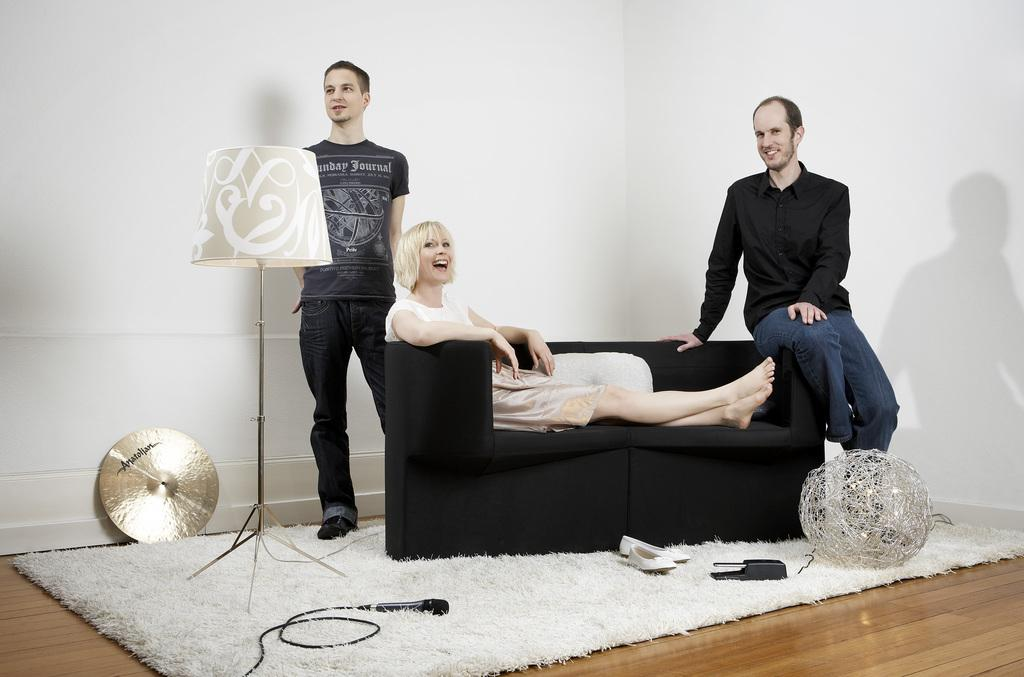What is the lady in the image doing? The lady is sitting on a sofa in the image. Who is sitting behind the lady? There is a man sitting behind the lady in the image. What is the position of the other man in the image? There is a man standing at one edge of the sofa in the image. What type of lighting is present in the image? There is a lamp in the image. What type of floor covering is visible in the image? There is a carpet in the image. What type of polish is the lady applying to her nails in the image? There is no indication in the image that the lady is applying polish to her nails. How many mice can be seen running around on the carpet in the image? There are no mice present in the image; it features a lady, two men, a sofa, a lamp, and a carpet. 